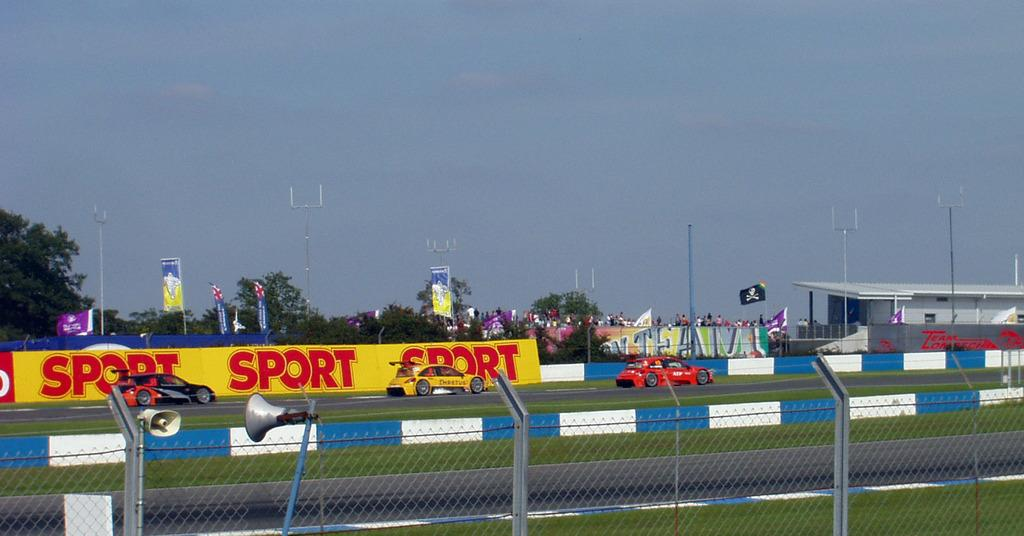Provide a one-sentence caption for the provided image. Cars race down a track past a sign that repeats the work sport three times. 